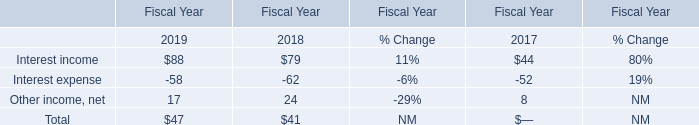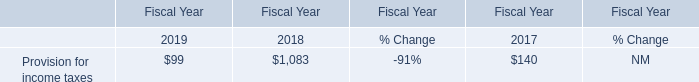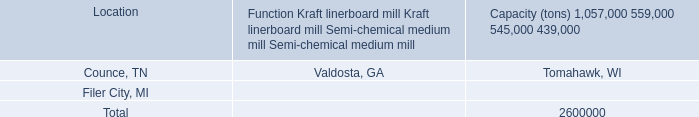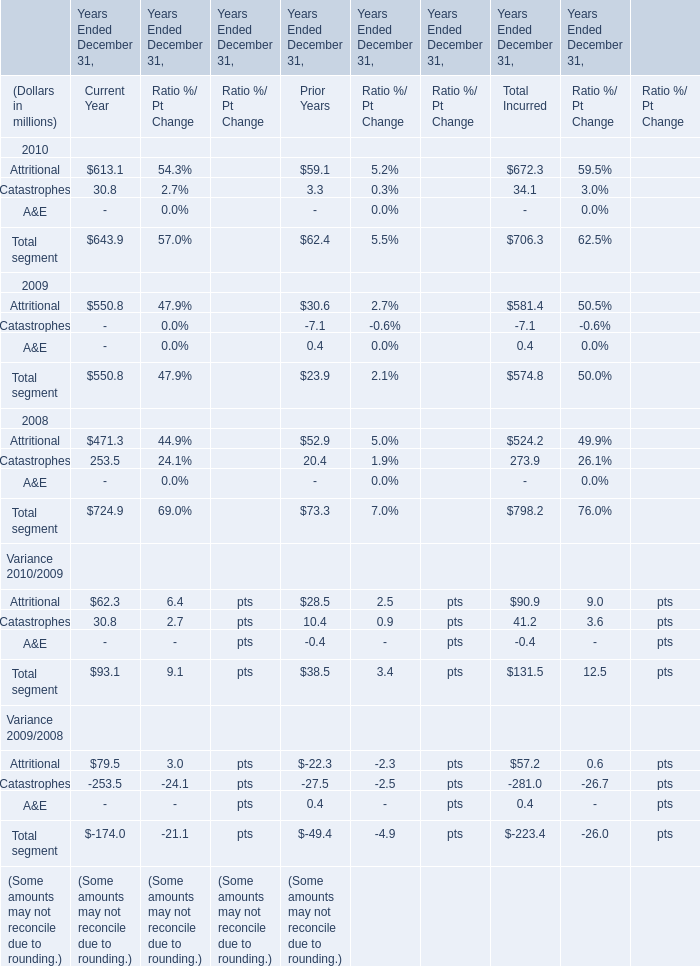Which year is total segment for total incurred the highest? 
Answer: 2008. 